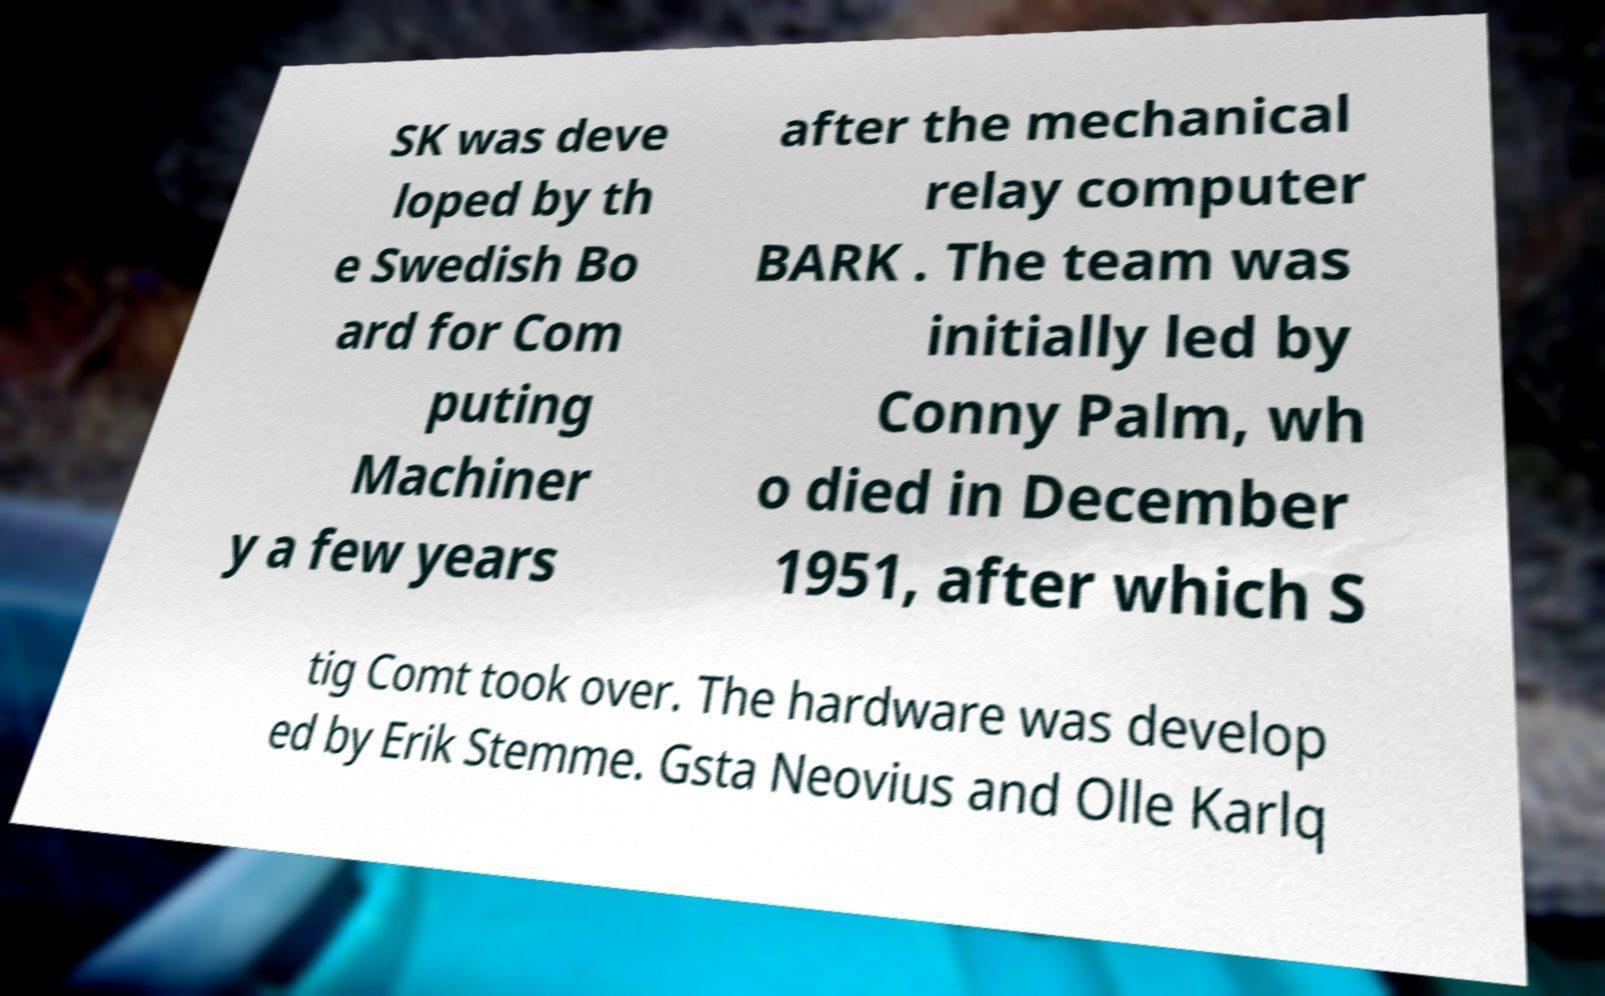Can you accurately transcribe the text from the provided image for me? SK was deve loped by th e Swedish Bo ard for Com puting Machiner y a few years after the mechanical relay computer BARK . The team was initially led by Conny Palm, wh o died in December 1951, after which S tig Comt took over. The hardware was develop ed by Erik Stemme. Gsta Neovius and Olle Karlq 